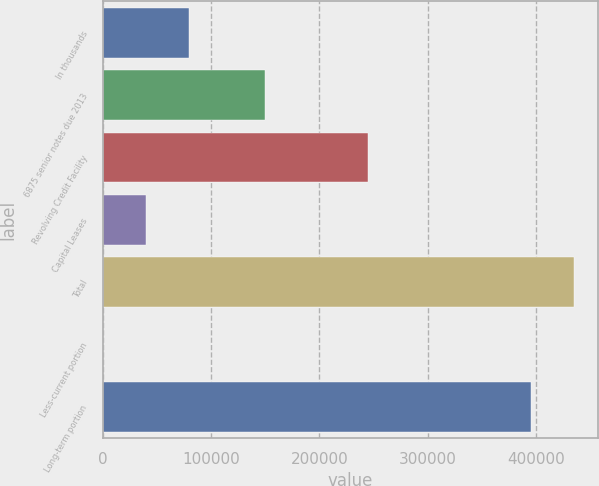Convert chart to OTSL. <chart><loc_0><loc_0><loc_500><loc_500><bar_chart><fcel>In thousands<fcel>6875 senior notes due 2013<fcel>Revolving Credit Facility<fcel>Capital Leases<fcel>Total<fcel>Less-current portion<fcel>Long-term portion<nl><fcel>79229<fcel>150000<fcel>245000<fcel>39648.5<fcel>435386<fcel>68<fcel>395805<nl></chart> 